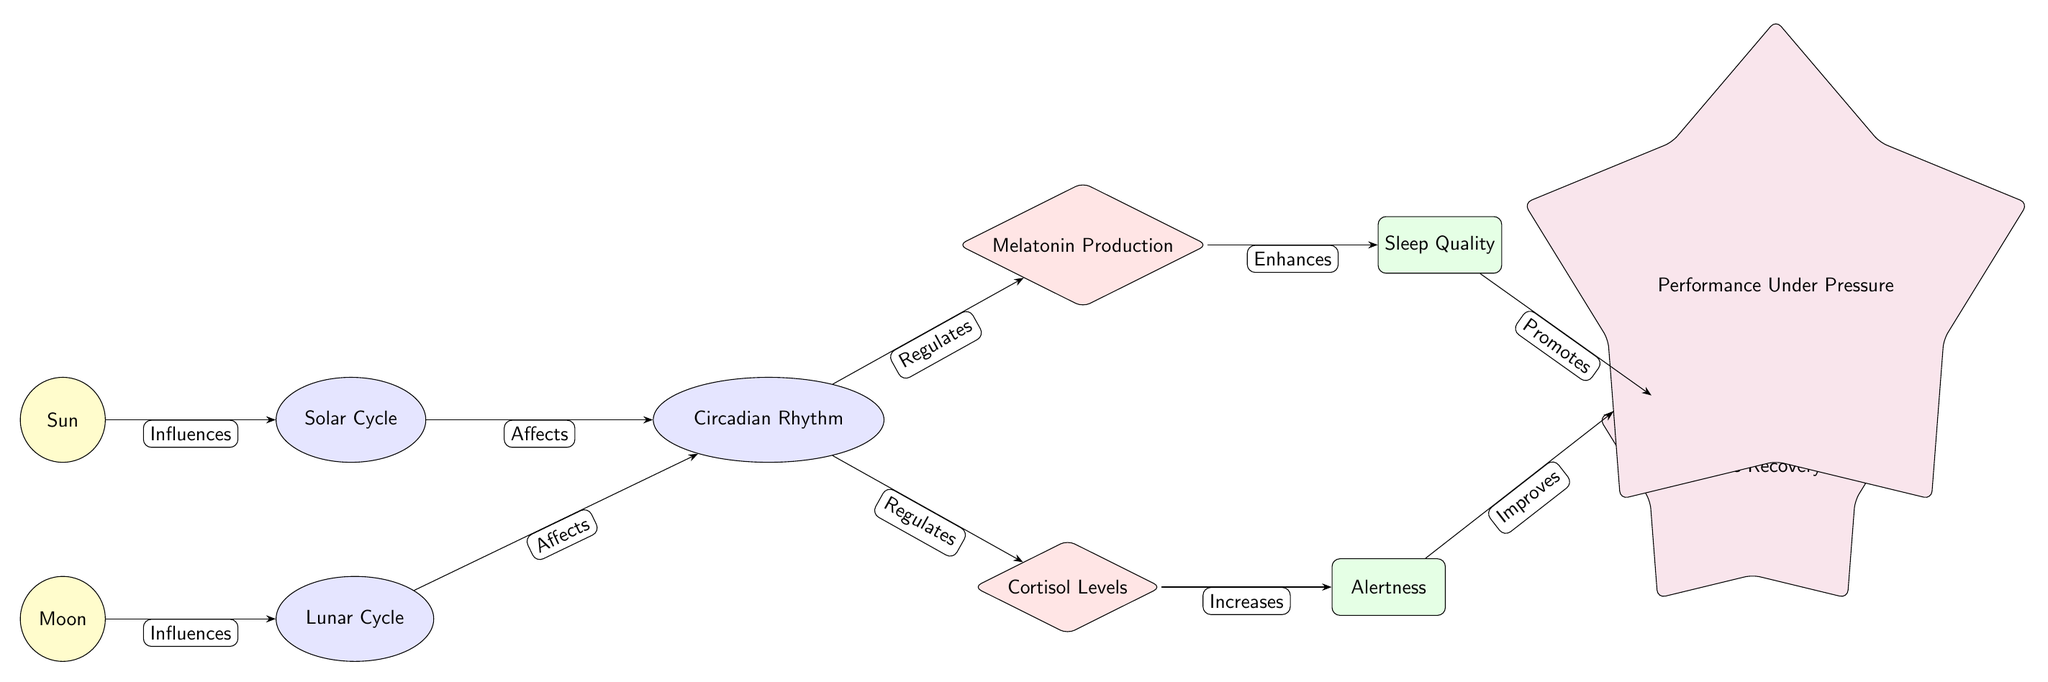What influences the Solar Cycle? The diagram indicates that the Sun influences the Solar Cycle. It shows a direct edge labeled "Influences" pointing from the Sun node to the Solar Cycle node.
Answer: Sun What does the Lunar Cycle affect? The diagram shows that the Lunar Cycle affects the Circadian Rhythm, as indicated by the edge labeled "Affects" that connects these two nodes.
Answer: Circadian Rhythm How many hormonal factors are present in the diagram? The diagram depicts two hormonal factors: Melatonin Production and Cortisol Levels. Counting these nodes gives a total of two.
Answer: 2 What is enhanced by Melatonin Production? According to the diagram, Melatonin Production enhances Sleep Quality, as indicated by the edge labeled "Enhances" connecting these two nodes.
Answer: Sleep Quality What effect does Alertness improve? The diagram illustrates that Alertness improves Performance Under Pressure, which is shown by the edge labeled "Improves" linking these two nodes.
Answer: Performance Under Pressure What does Circadian Rhythm regulate? The Circadian Rhythm regulates both Melatonin Production and Cortisol Levels. The diagram has edges labeled "Regulates" pointing to these two hormone nodes.
Answer: Melatonin Production and Cortisol Levels Which cycle has a direct effect on both hormones in the diagram? The diagram shows that both the Solar Cycle and Lunar Cycle affect the Circadian Rhythm, which in turn regulates Melatonin Production and Cortisol Levels. Therefore, both cycles are involved in the hormonal effects indirectly.
Answer: Solar Cycle and Lunar Cycle What is promoted by Sleep Quality? Sleep Quality promotes Muscle Recovery, as indicated by the edge labeled "Promotes" that connects these two nodes in the diagram.
Answer: Muscle Recovery What nodes are connected by edges labeled "Affects"? The diagram displays two edges both labeled "Affects": one connects the Solar Cycle to the Circadian Rhythm and the other connects the Lunar Cycle to the Circadian Rhythm, showing both cycles influence it.
Answer: Solar Cycle and Lunar Cycle 